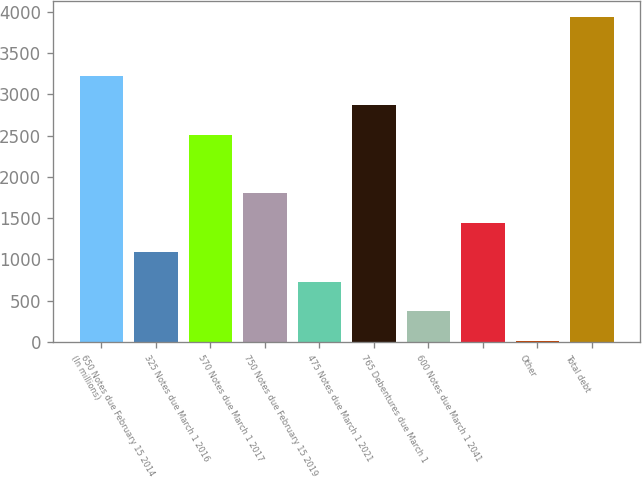Convert chart to OTSL. <chart><loc_0><loc_0><loc_500><loc_500><bar_chart><fcel>(In millions)<fcel>650 Notes due February 15 2014<fcel>325 Notes due March 1 2016<fcel>570 Notes due March 1 2017<fcel>750 Notes due February 15 2019<fcel>475 Notes due March 1 2021<fcel>765 Debentures due March 1<fcel>600 Notes due March 1 2041<fcel>Other<fcel>Total debt<nl><fcel>3223.8<fcel>1086.6<fcel>2511.4<fcel>1799<fcel>730.4<fcel>2867.6<fcel>374.2<fcel>1442.8<fcel>18<fcel>3936.2<nl></chart> 